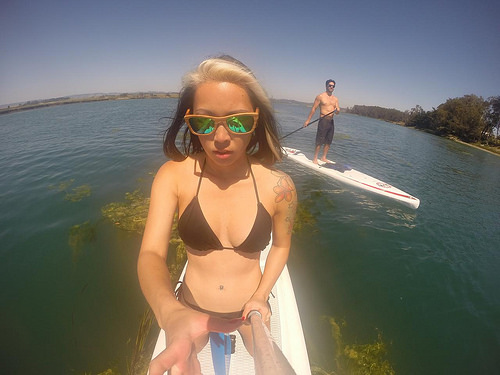<image>
Is the woman on the surf board? Yes. Looking at the image, I can see the woman is positioned on top of the surf board, with the surf board providing support. Is there a guy behind the girl? Yes. From this viewpoint, the guy is positioned behind the girl, with the girl partially or fully occluding the guy. Where is the woman in relation to the paddle board? Is it next to the paddle board? Yes. The woman is positioned adjacent to the paddle board, located nearby in the same general area. 